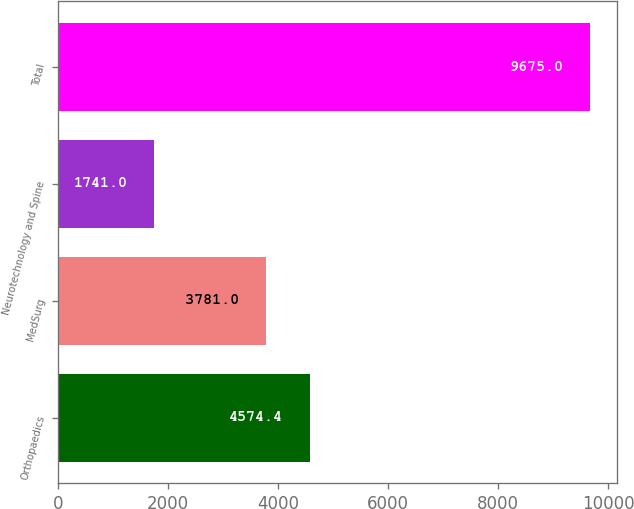Convert chart to OTSL. <chart><loc_0><loc_0><loc_500><loc_500><bar_chart><fcel>Orthopaedics<fcel>MedSurg<fcel>Neurotechnology and Spine<fcel>Total<nl><fcel>4574.4<fcel>3781<fcel>1741<fcel>9675<nl></chart> 